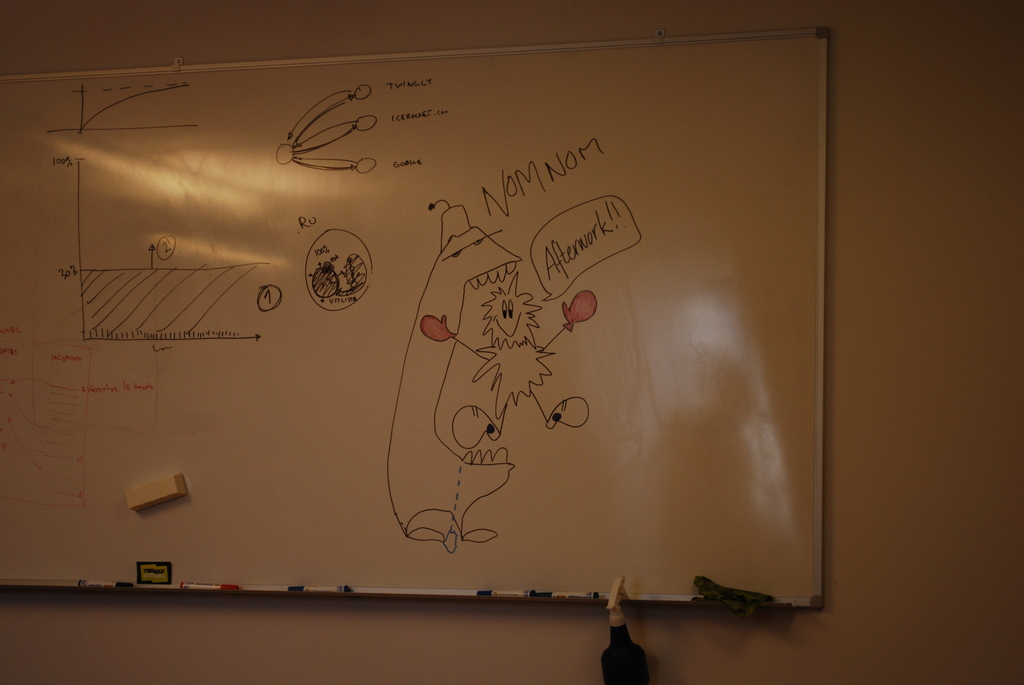What does the diagram on the left side of the whiteboard represent? The diagram on the left appears to be a scientific graph, probably illustrating some physics concepts related to velocity and distance over time, marked by labels such as '100 ft' and axis. 